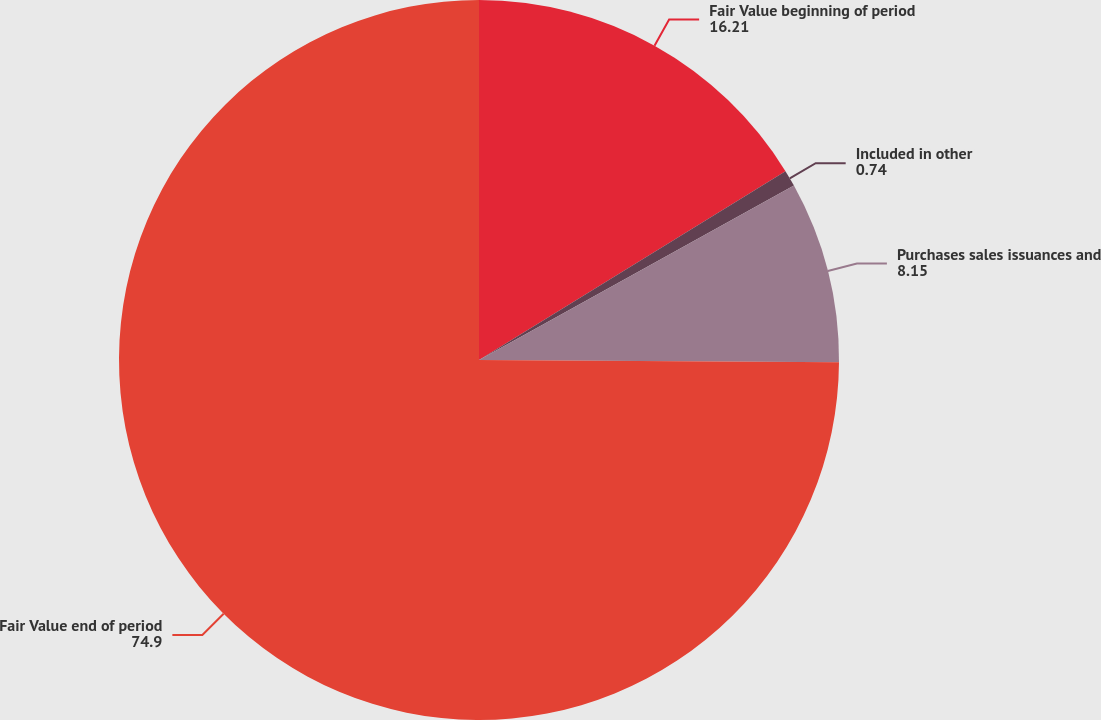Convert chart. <chart><loc_0><loc_0><loc_500><loc_500><pie_chart><fcel>Fair Value beginning of period<fcel>Included in other<fcel>Purchases sales issuances and<fcel>Fair Value end of period<nl><fcel>16.21%<fcel>0.74%<fcel>8.15%<fcel>74.9%<nl></chart> 